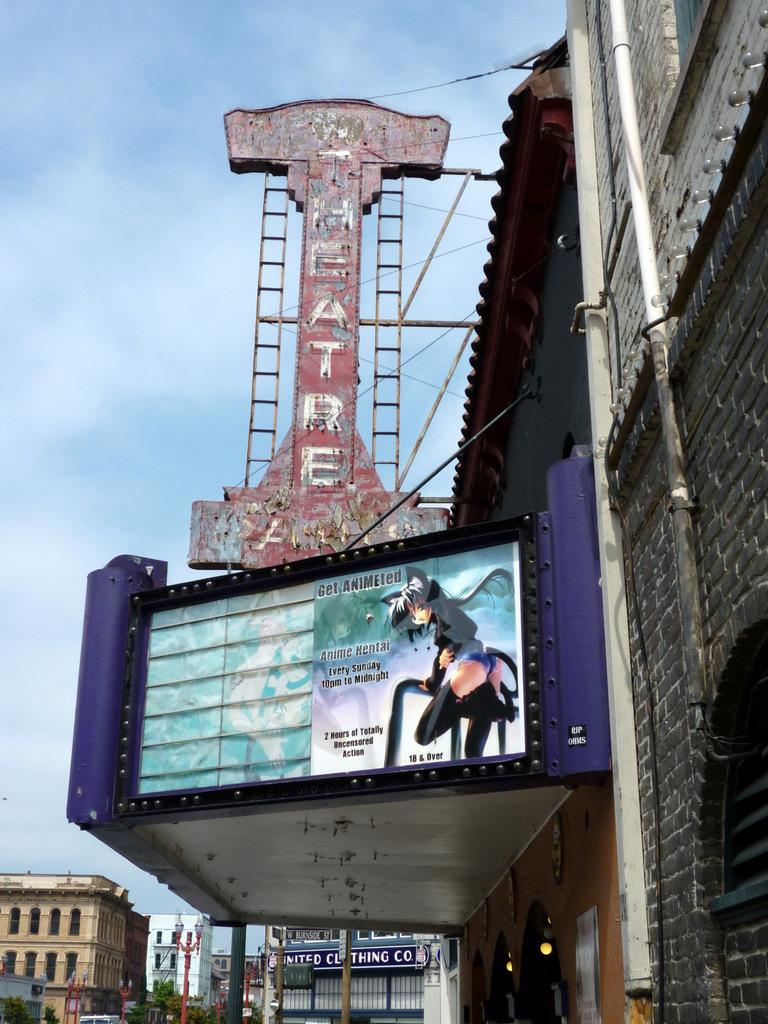<image>
Provide a brief description of the given image. An old theater is showing anime on Sunday nights for ages 18 and over. 